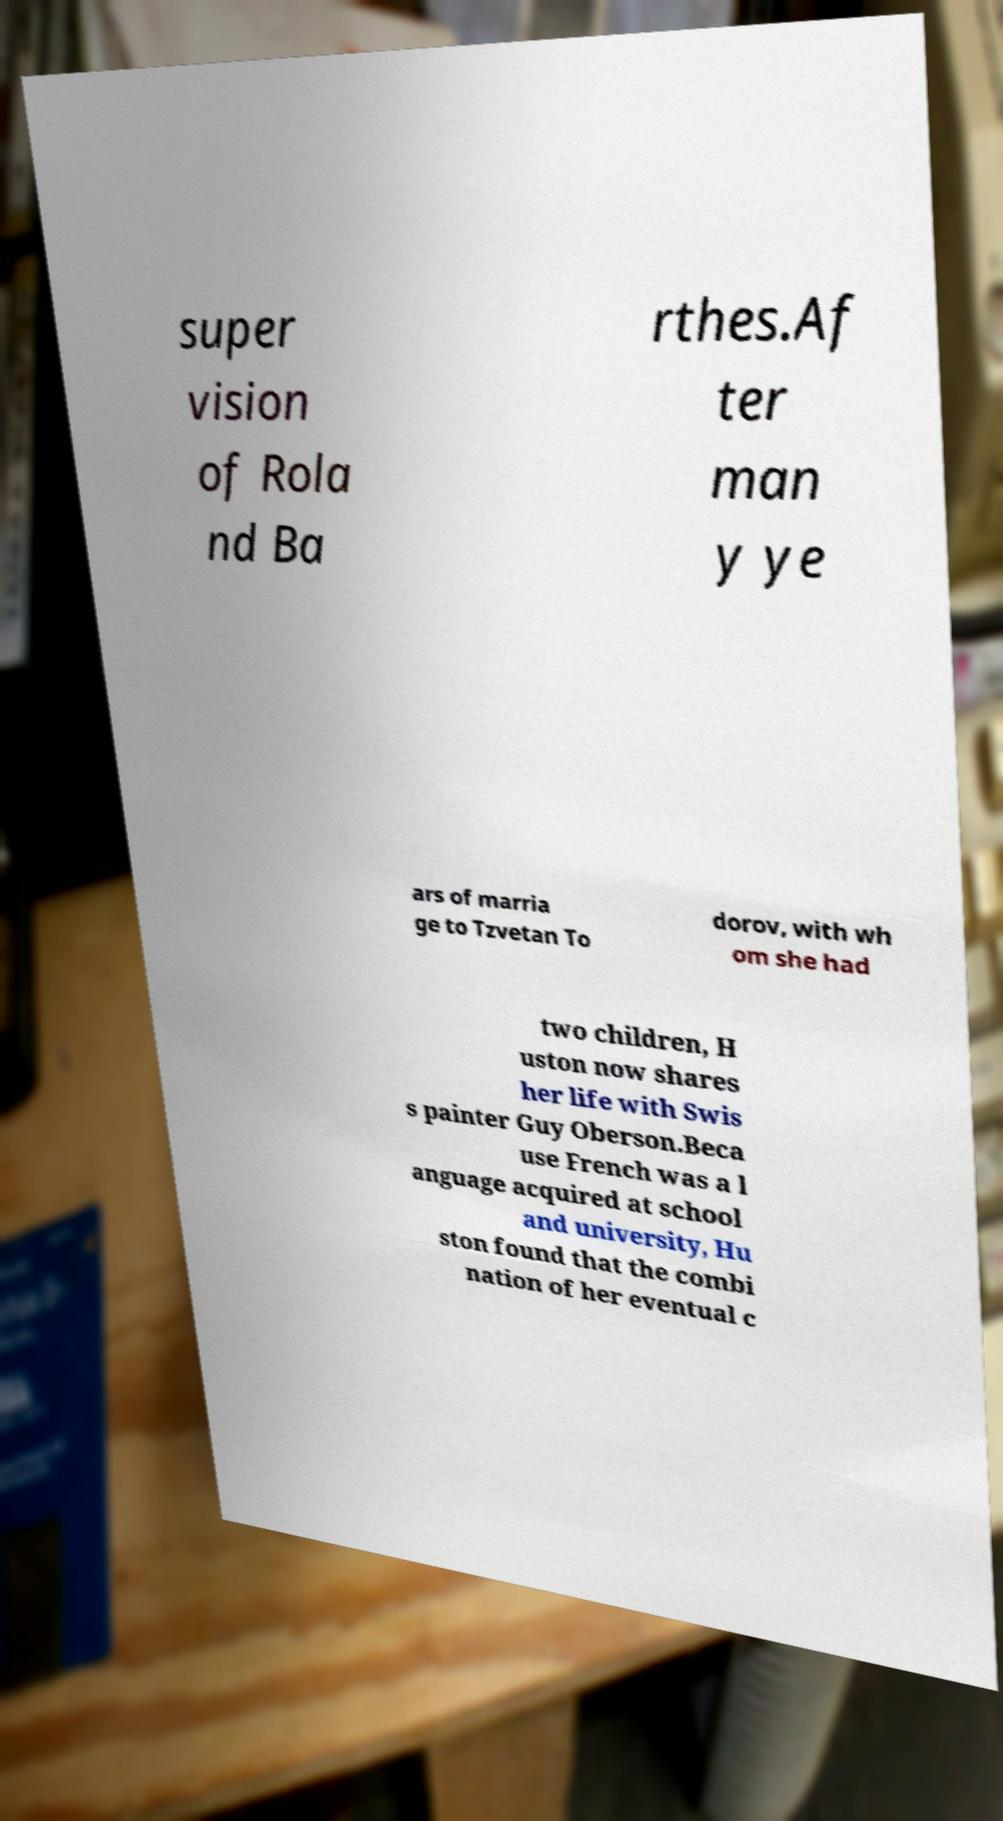Can you read and provide the text displayed in the image?This photo seems to have some interesting text. Can you extract and type it out for me? super vision of Rola nd Ba rthes.Af ter man y ye ars of marria ge to Tzvetan To dorov, with wh om she had two children, H uston now shares her life with Swis s painter Guy Oberson.Beca use French was a l anguage acquired at school and university, Hu ston found that the combi nation of her eventual c 